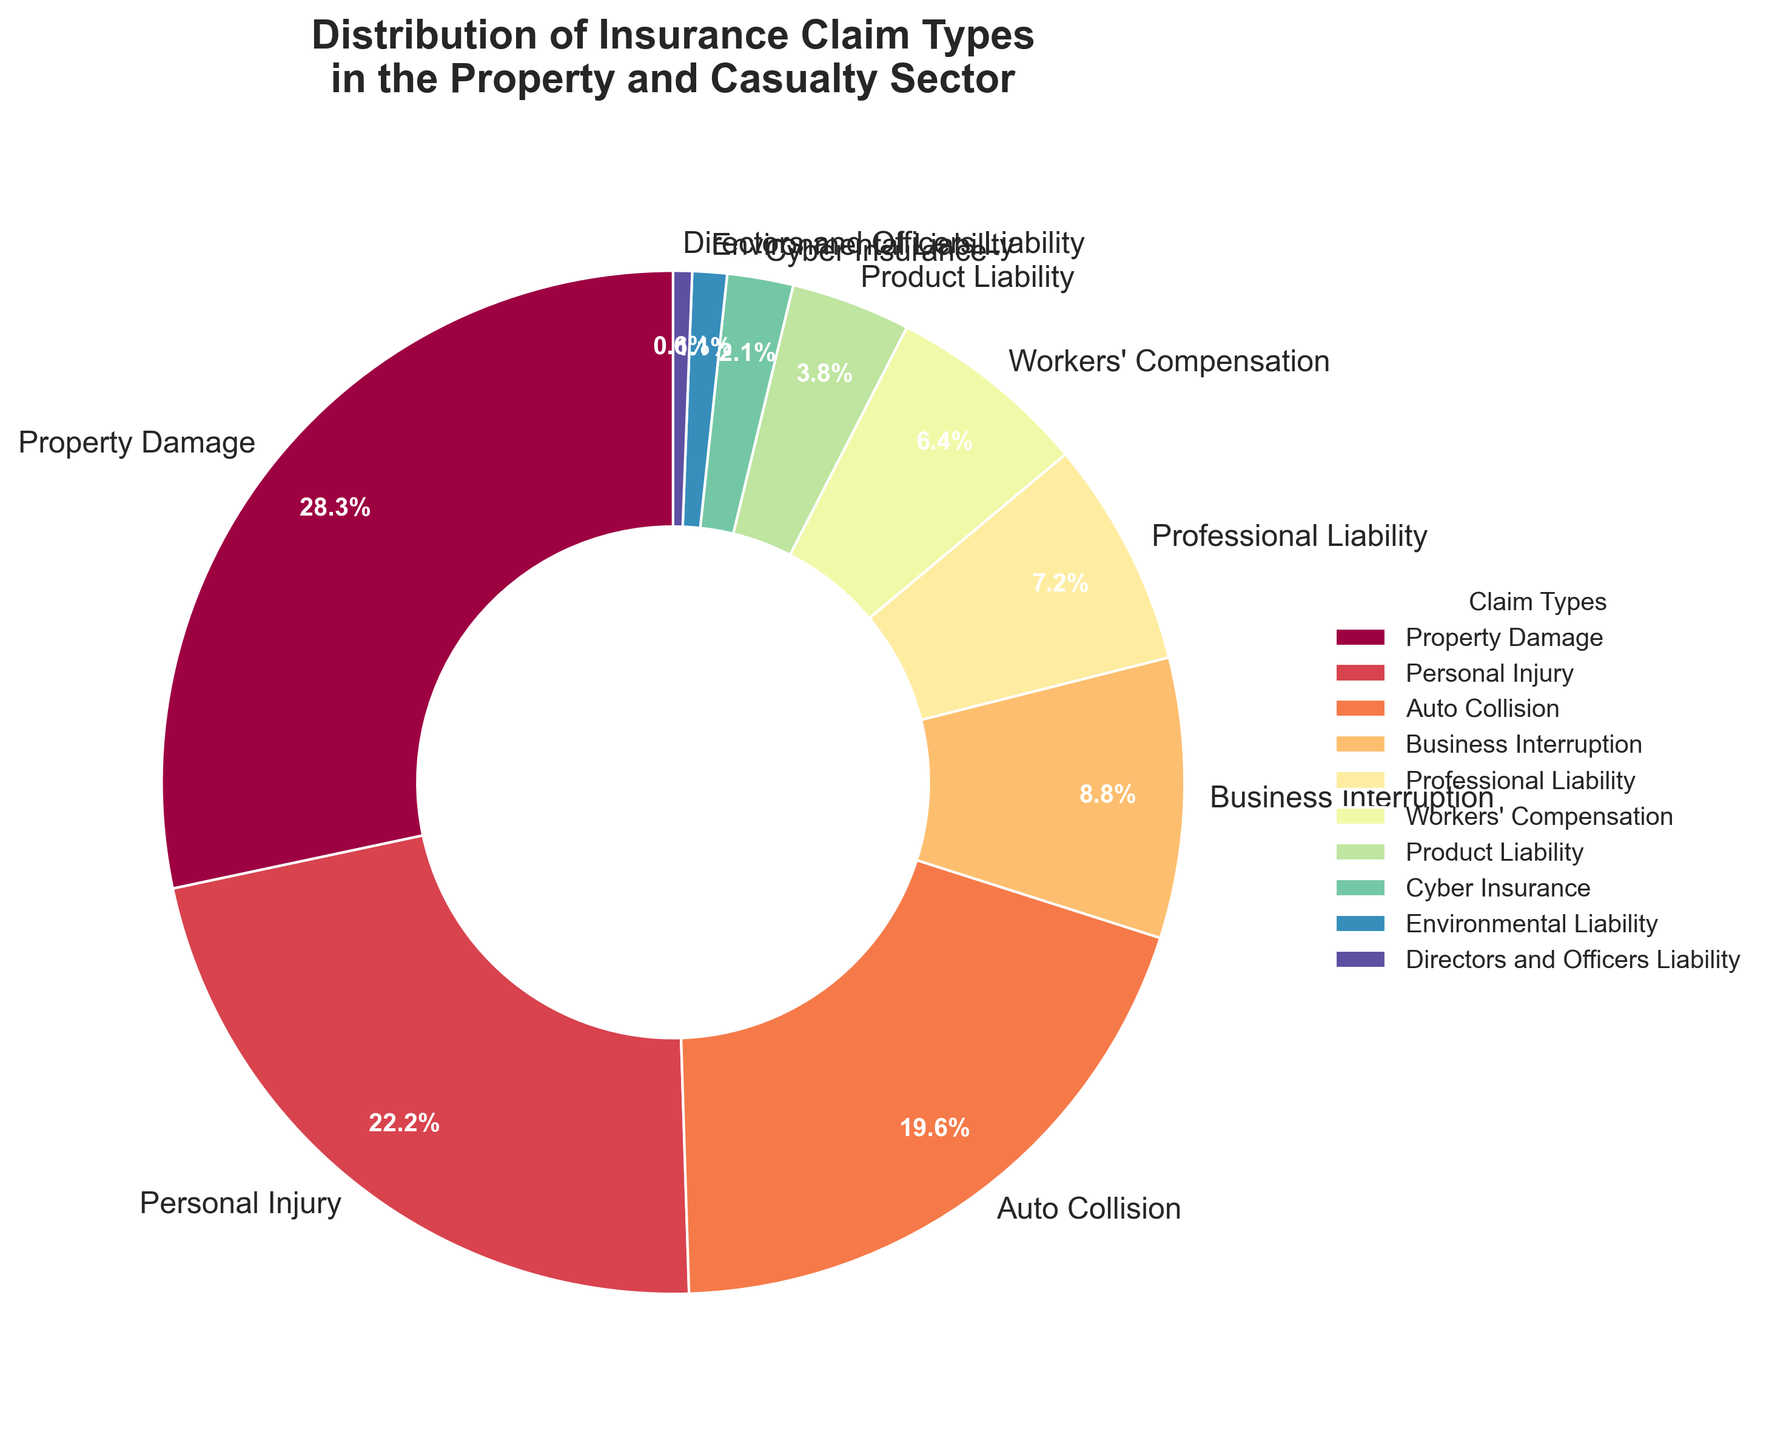What is the claim type with the highest percentage? Visually identify the largest segment in the pie chart. Scan for the segment covering the largest angular area and note the label.
Answer: Property Damage Which claim type has a lower percentage, Business Interruption or Professional Liability? Compare the size of the Business Interruption and Professional Liability segments. Identify their percentages and determine which is smaller.
Answer: Professional Liability What is the sum of the percentages for Property Damage, Personal Injury, and Auto Collision? Find the percentages for Property Damage (28.5%), Personal Injury (22.3%), and Auto Collision (19.7%), then sum them: 28.5 + 22.3 + 19.7.
Answer: 70.5% Which claim types combined make up more than 50% of the total? Identify the percentages contributing more than 50%. Adding the three highest: Property Damage (28.5%) + Personal Injury (22.3%) + Auto Collision (19.7%) exceeds 50%.
Answer: Property Damage, Personal Injury, and Auto Collision What is the difference in percentage between Workers' Compensation and Cyber Insurance? Subtract the percentage of Cyber Insurance (2.1%) from Workers' Compensation (6.4%): 6.4 - 2.1.
Answer: 4.3% Which claim type represents the smallest percentage on the pie chart? Identify the smallest segment visually and note its label. The smallest segment will cover the least angular area.
Answer: Directors and Officers Liability How many claim types have a percentage greater than 10%? Identify and count segments with percentages greater than 10%. These are Property Damage and Personal Injury.
Answer: 2 claim types Is the percentage for Product Liability more than twice that for Cyber Insurance? Compare twice the percentage for Cyber Insurance (2.1 * 2 = 4.2%) with Product Liability (3.8%). Since 3.8% < 4.2%, it's not more than twice.
Answer: No What percentage of the total is represented by claim types with less than 5% each? Identify and sum percentages for segments less than 5%: Product Liability (3.8%), Cyber Insurance (2.1%), Environmental Liability (1.1%), and Directors and Officers Liability (0.6%): 3.8 + 2.1 + 1.1 + 0.6.
Answer: 7.6% Which claim type is closest in percentage to Professional Liability? Compare the percentage of Professional Liability (7.2%) with the percentages of surrounding types and find the closest match. Workers' Compensation (6.4%) is the nearest.
Answer: Workers' Compensation 